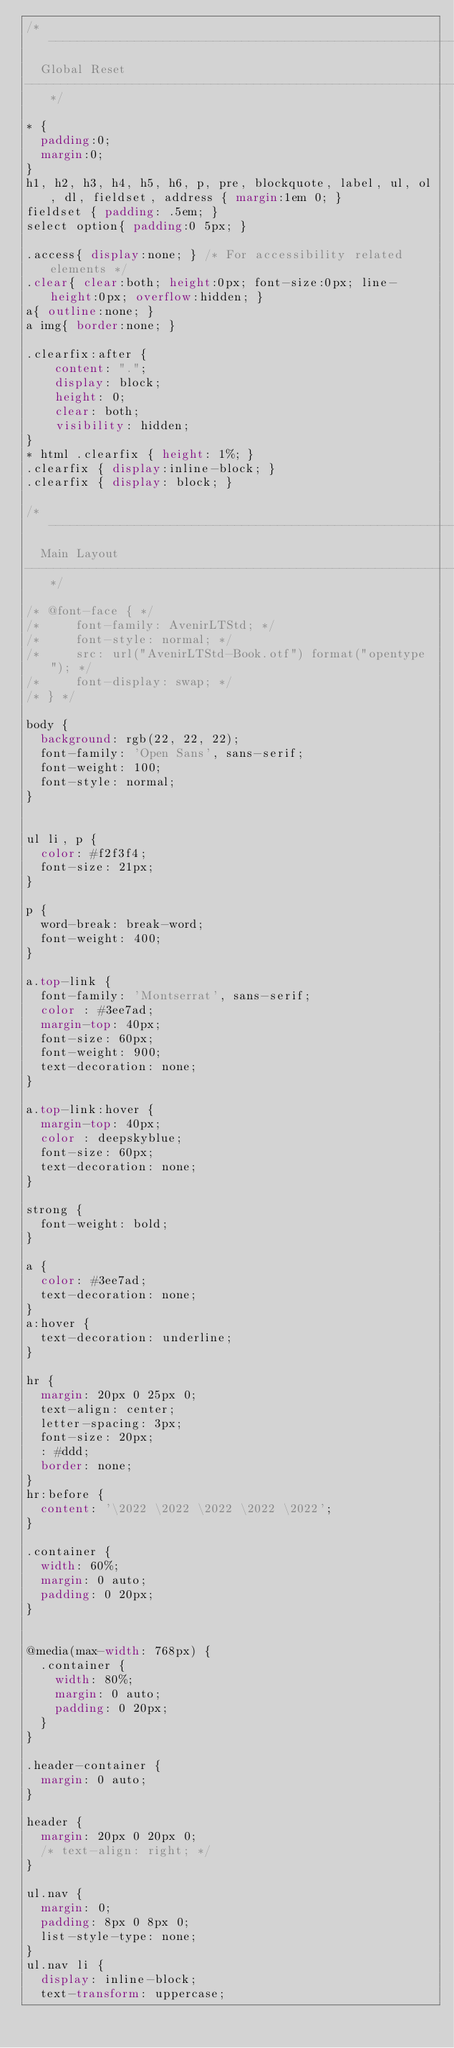Convert code to text. <code><loc_0><loc_0><loc_500><loc_500><_CSS_>/*----------------------------------------------------------------------------
  Global Reset
----------------------------------------------------------------------------*/

* {
  padding:0;
  margin:0;
}
h1, h2, h3, h4, h5, h6, p, pre, blockquote, label, ul, ol, dl, fieldset, address { margin:1em 0; }
fieldset { padding: .5em; }
select option{ padding:0 5px; }

.access{ display:none; } /* For accessibility related elements */
.clear{ clear:both; height:0px; font-size:0px; line-height:0px; overflow:hidden; }
a{ outline:none; }
a img{ border:none; }

.clearfix:after {
    content: ".";
    display: block;
    height: 0;
    clear: both;
    visibility: hidden;
}
* html .clearfix { height: 1%; }
.clearfix { display:inline-block; }
.clearfix { display: block; }

/*----------------------------------------------------------------------------
  Main Layout
----------------------------------------------------------------------------*/

/* @font-face { */
/*     font-family: AvenirLTStd; */
/*     font-style: normal; */
/*     src: url("AvenirLTStd-Book.otf") format("opentype"); */
/*     font-display: swap; */
/* } */

body {
  background: rgb(22, 22, 22);
  font-family: 'Open Sans', sans-serif;
  font-weight: 100;
  font-style: normal;
}


ul li, p {
  color: #f2f3f4;
  font-size: 21px;
}

p {
  word-break: break-word;
  font-weight: 400;
}

a.top-link {
  font-family: 'Montserrat', sans-serif;
  color : #3ee7ad;
  margin-top: 40px;
  font-size: 60px;
  font-weight: 900;
  text-decoration: none;
}

a.top-link:hover {
  margin-top: 40px;
  color : deepskyblue;
  font-size: 60px;
  text-decoration: none;
}

strong {
  font-weight: bold;
}

a {
  color: #3ee7ad;
  text-decoration: none;
}
a:hover {
  text-decoration: underline;
}

hr {
  margin: 20px 0 25px 0;
  text-align: center;
  letter-spacing: 3px;
  font-size: 20px;
  : #ddd;
  border: none;
}
hr:before {
  content: '\2022 \2022 \2022 \2022 \2022';
}

.container {
  width: 60%;
  margin: 0 auto;
  padding: 0 20px;
}


@media(max-width: 768px) {
  .container {
    width: 80%;
    margin: 0 auto;
    padding: 0 20px;
  }
}

.header-container {
  margin: 0 auto;
}

header {
  margin: 20px 0 20px 0;
  /* text-align: right; */
}

ul.nav {
  margin: 0;
  padding: 8px 0 8px 0;
  list-style-type: none;
}
ul.nav li {
  display: inline-block;
  text-transform: uppercase;</code> 